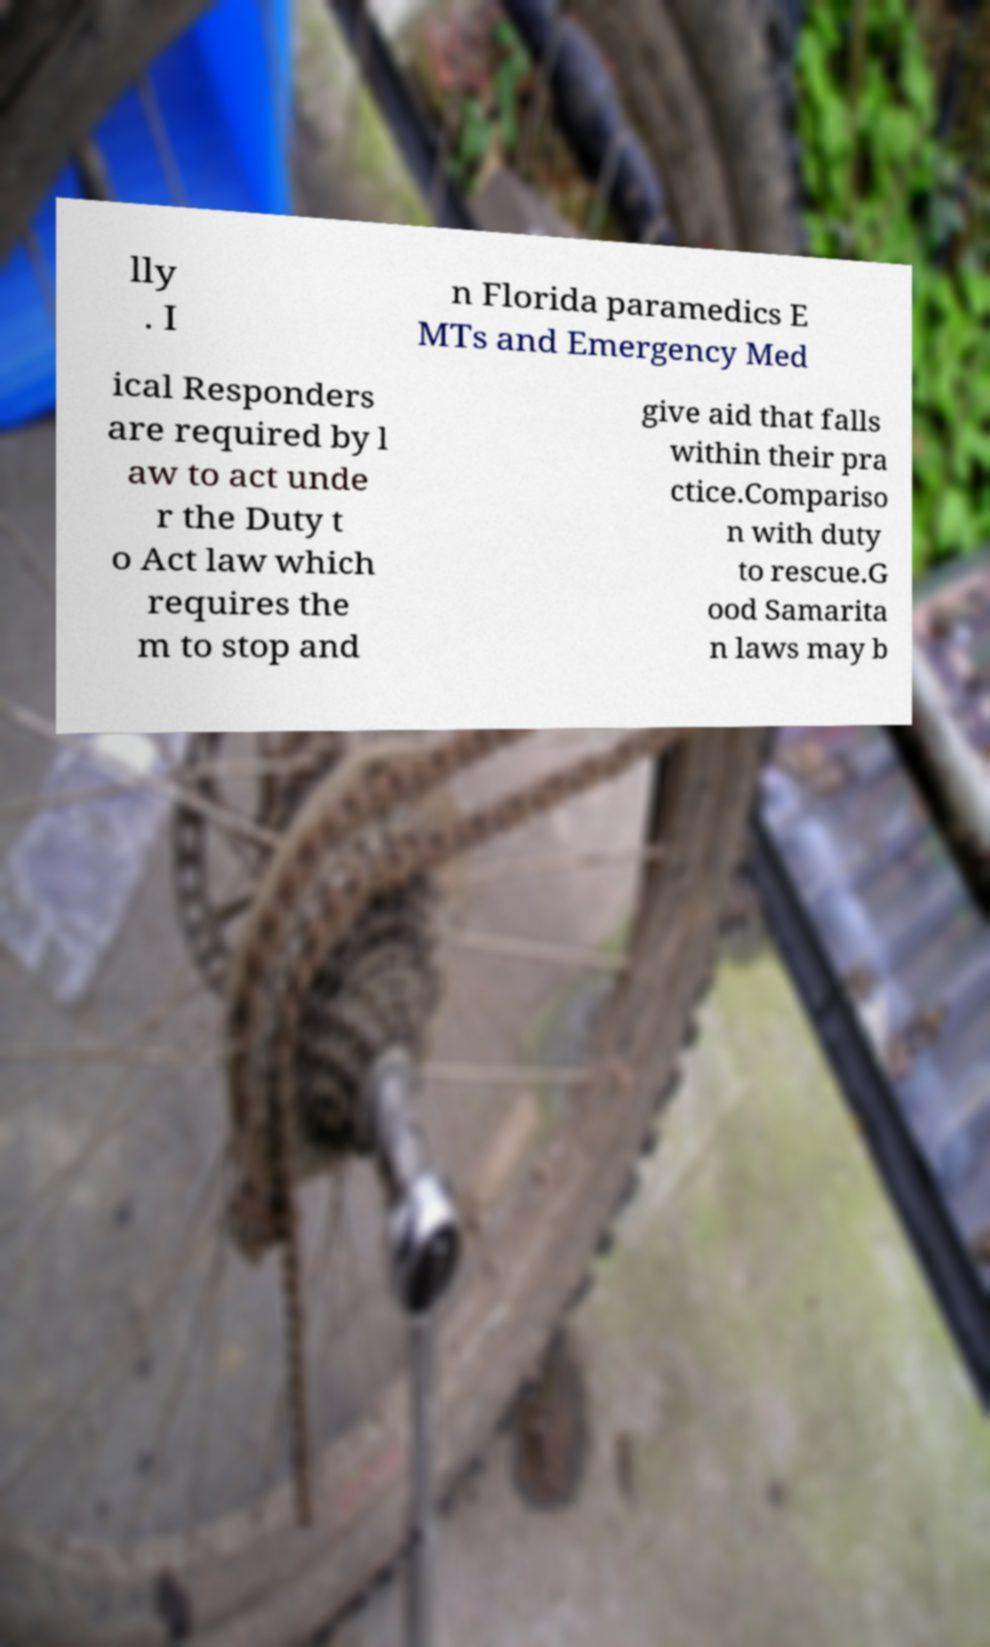There's text embedded in this image that I need extracted. Can you transcribe it verbatim? lly . I n Florida paramedics E MTs and Emergency Med ical Responders are required by l aw to act unde r the Duty t o Act law which requires the m to stop and give aid that falls within their pra ctice.Compariso n with duty to rescue.G ood Samarita n laws may b 